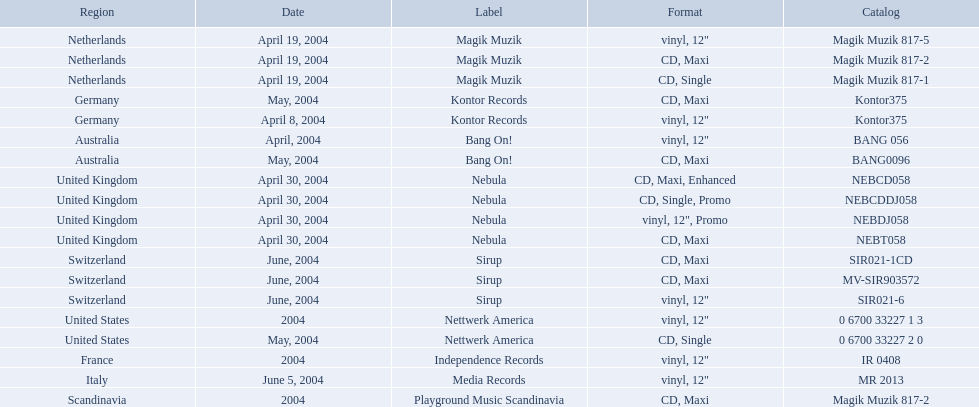What are all of the regions the title was released in? Netherlands, Netherlands, Netherlands, Germany, Germany, Australia, Australia, United Kingdom, United Kingdom, United Kingdom, United Kingdom, Switzerland, Switzerland, Switzerland, United States, United States, France, Italy, Scandinavia. And under which labels were they released? Magik Muzik, Magik Muzik, Magik Muzik, Kontor Records, Kontor Records, Bang On!, Bang On!, Nebula, Nebula, Nebula, Nebula, Sirup, Sirup, Sirup, Nettwerk America, Nettwerk America, Independence Records, Media Records, Playground Music Scandinavia. Which label released the song in france? Independence Records. Parse the table in full. {'header': ['Region', 'Date', 'Label', 'Format', 'Catalog'], 'rows': [['Netherlands', 'April 19, 2004', 'Magik Muzik', 'vinyl, 12"', 'Magik Muzik 817-5'], ['Netherlands', 'April 19, 2004', 'Magik Muzik', 'CD, Maxi', 'Magik Muzik 817-2'], ['Netherlands', 'April 19, 2004', 'Magik Muzik', 'CD, Single', 'Magik Muzik 817-1'], ['Germany', 'May, 2004', 'Kontor Records', 'CD, Maxi', 'Kontor375'], ['Germany', 'April 8, 2004', 'Kontor Records', 'vinyl, 12"', 'Kontor375'], ['Australia', 'April, 2004', 'Bang On!', 'vinyl, 12"', 'BANG 056'], ['Australia', 'May, 2004', 'Bang On!', 'CD, Maxi', 'BANG0096'], ['United Kingdom', 'April 30, 2004', 'Nebula', 'CD, Maxi, Enhanced', 'NEBCD058'], ['United Kingdom', 'April 30, 2004', 'Nebula', 'CD, Single, Promo', 'NEBCDDJ058'], ['United Kingdom', 'April 30, 2004', 'Nebula', 'vinyl, 12", Promo', 'NEBDJ058'], ['United Kingdom', 'April 30, 2004', 'Nebula', 'CD, Maxi', 'NEBT058'], ['Switzerland', 'June, 2004', 'Sirup', 'CD, Maxi', 'SIR021-1CD'], ['Switzerland', 'June, 2004', 'Sirup', 'CD, Maxi', 'MV-SIR903572'], ['Switzerland', 'June, 2004', 'Sirup', 'vinyl, 12"', 'SIR021-6'], ['United States', '2004', 'Nettwerk America', 'vinyl, 12"', '0 6700 33227 1 3'], ['United States', 'May, 2004', 'Nettwerk America', 'CD, Single', '0 6700 33227 2 0'], ['France', '2004', 'Independence Records', 'vinyl, 12"', 'IR 0408'], ['Italy', 'June 5, 2004', 'Media Records', 'vinyl, 12"', 'MR 2013'], ['Scandinavia', '2004', 'Playground Music Scandinavia', 'CD, Maxi', 'Magik Muzik 817-2']]} What are the tags for "love comes again"? Magik Muzik, Magik Muzik, Magik Muzik, Kontor Records, Kontor Records, Bang On!, Bang On!, Nebula, Nebula, Nebula, Nebula, Sirup, Sirup, Sirup, Nettwerk America, Nettwerk America, Independence Records, Media Records, Playground Music Scandinavia. Which designation has been utilized by the french region? Independence Records. What labels can be found for "love comes again"? Magik Muzik, Magik Muzik, Magik Muzik, Kontor Records, Kontor Records, Bang On!, Bang On!, Nebula, Nebula, Nebula, Nebula, Sirup, Sirup, Sirup, Nettwerk America, Nettwerk America, Independence Records, Media Records, Playground Music Scandinavia. What label is commonly used in the french region? Independence Records. 